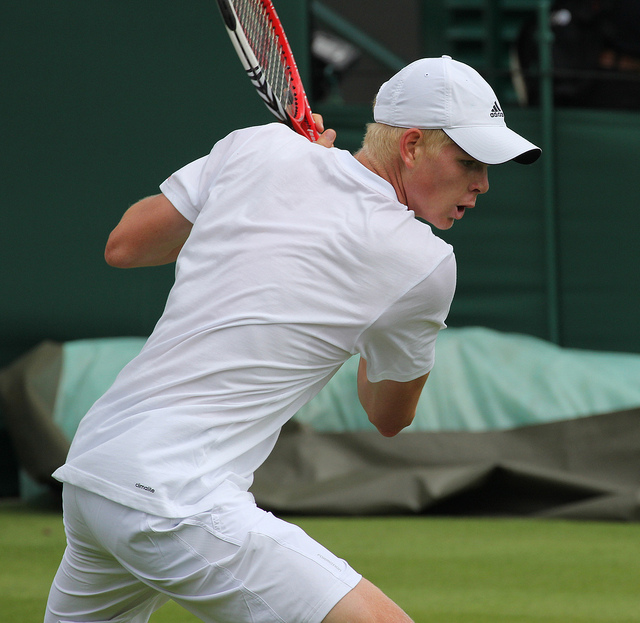<image>What team is he playing? I don't know what team he is playing. It could be the red sox, mets, or tennis. Who will win this game? It is uncertain who will win this game. What team is he playing? I don't know what team he is playing. It can be 'red sox', 'tennis', 'mets' or 'none'. Who will win this game? I don't know who will win this game. It can be any of the tennis player, one of the players, or the man wearing white. 